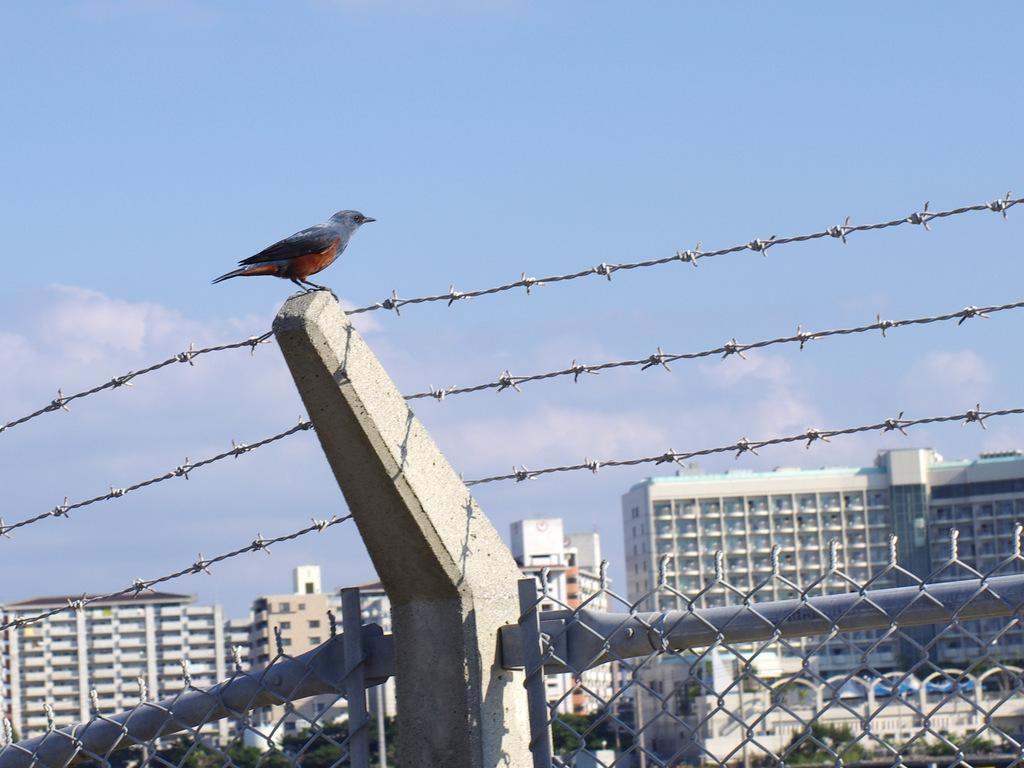What type of structure can be seen in the image? There is fencing in the image. What animal is present on a stone in the image? There is a bird on a stone in the image. What can be seen in the distance in the image? There are buildings and trees in the background of the image. How would you describe the sky in the image? The sky is clear in the background of the image. Where is the oil stored in the image? There is no oil present in the image. What type of writing instrument is the bird holding in the image? The bird is not holding any writing instrument in the image; it is simply perched on a stone. 